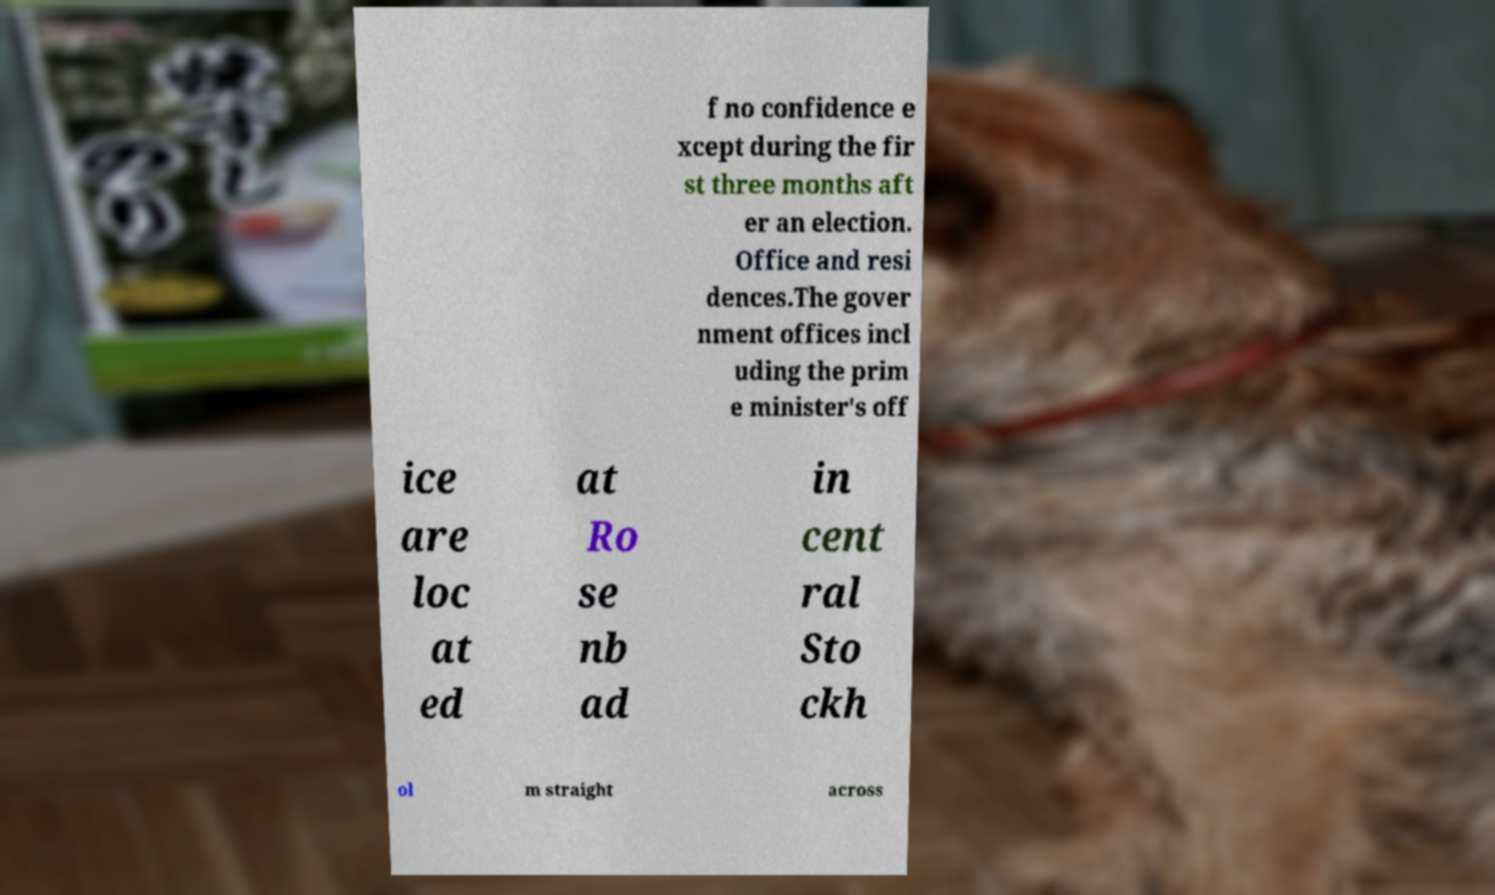Could you assist in decoding the text presented in this image and type it out clearly? f no confidence e xcept during the fir st three months aft er an election. Office and resi dences.The gover nment offices incl uding the prim e minister's off ice are loc at ed at Ro se nb ad in cent ral Sto ckh ol m straight across 